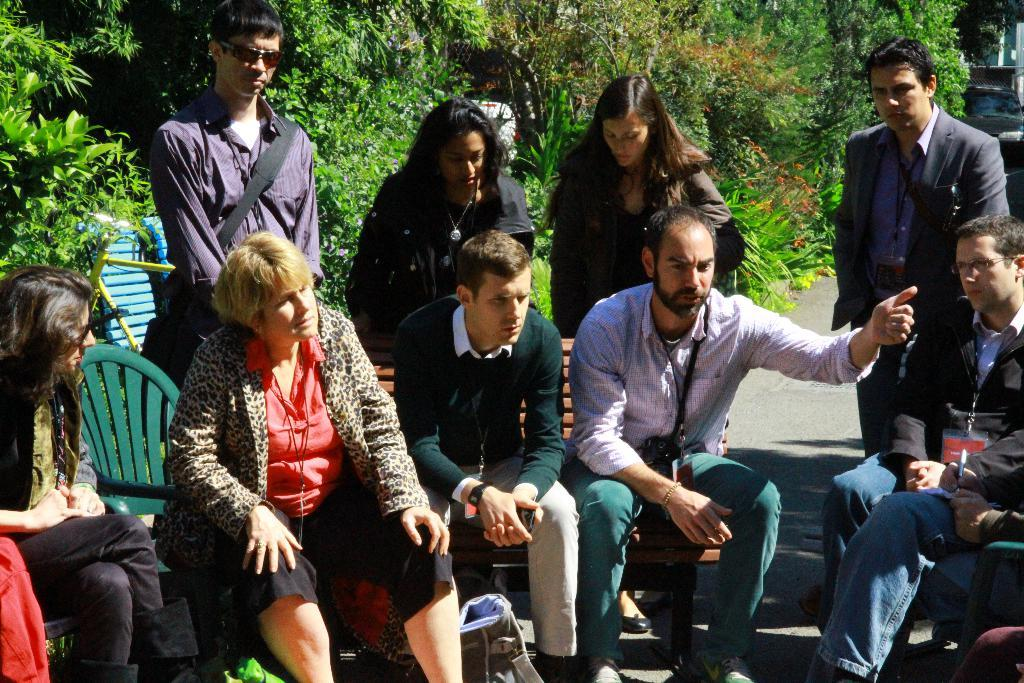What are the people in the center of the image doing? There are people sitting on chairs in the center of the image. Can you describe the positions of the people in the image? In addition to the people sitting on chairs, there are people standing in the image. What can be seen in the background of the image? There are trees in the background of the image. What type of bread is being used to exercise the muscles of the people in the image? There is no bread or exercise depicted in the image; it features people sitting on chairs and standing with trees in the background. 